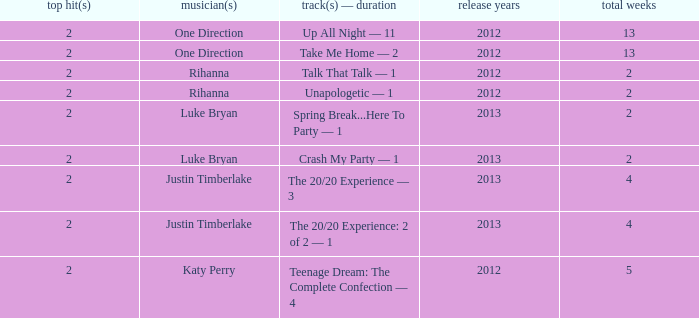What is the title of every song, and how many weeks was each song at #1 for One Direction? Up All Night — 11, Take Me Home — 2. 